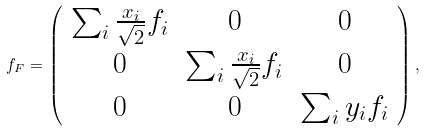<formula> <loc_0><loc_0><loc_500><loc_500>f _ { F } = \left ( \begin{array} { c c c } { { \sum _ { i } \frac { x _ { i } } { \sqrt { 2 } } f _ { i } } } & { 0 } & { 0 } \\ { 0 } & { { \sum _ { i } \frac { x _ { i } } { \sqrt { 2 } } f _ { i } } } & { 0 } \\ { 0 } & { 0 } & { { \sum _ { i } y _ { i } f _ { i } } } \end{array} \right ) ,</formula> 